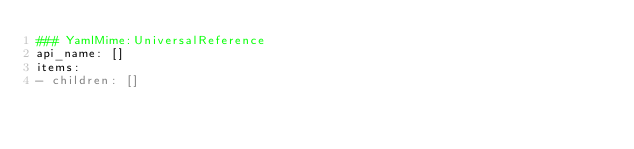<code> <loc_0><loc_0><loc_500><loc_500><_YAML_>### YamlMime:UniversalReference
api_name: []
items:
- children: []</code> 